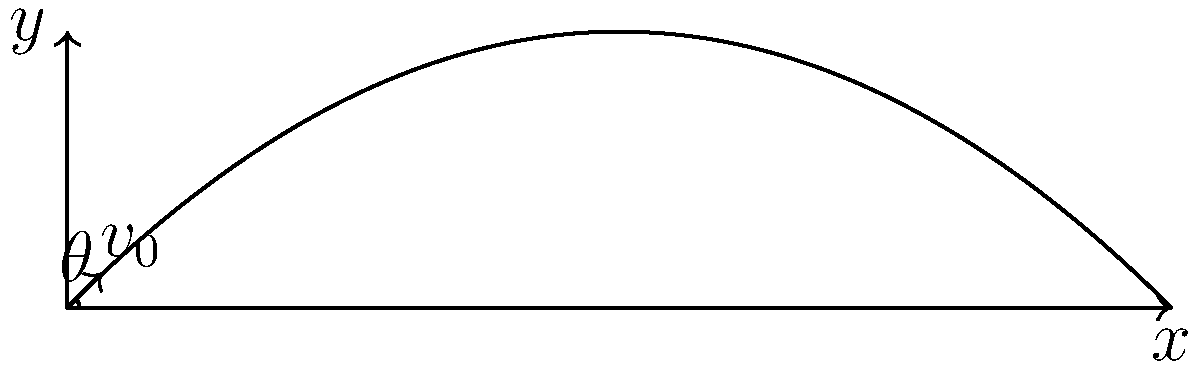As a professional football player, you're practicing your kicks. You kick a football with an initial velocity of 25 m/s at an angle of 45° above the horizontal. Assuming no air resistance, calculate the maximum height reached by the football during its trajectory. To solve this problem, we'll use the equations of projectile motion:

1. Identify the given information:
   - Initial velocity, $v_0 = 25$ m/s
   - Angle of projection, $\theta = 45°$
   - Acceleration due to gravity, $g = 9.8$ m/s²

2. The maximum height is reached when the vertical component of velocity becomes zero. We can use the equation:
   $y_{max} = \frac{v_0^2 \sin^2\theta}{2g}$

3. Convert the angle to radians:
   $45° = \frac{\pi}{4}$ radians

4. Calculate $\sin^2\theta$:
   $\sin^2(\frac{\pi}{4}) = (\frac{\sqrt{2}}{2})^2 = \frac{1}{2}$

5. Substitute the values into the equation:
   $y_{max} = \frac{(25\text{ m/s})^2 \cdot \frac{1}{2}}{2 \cdot 9.8\text{ m/s²}}$

6. Simplify:
   $y_{max} = \frac{625\text{ m²/s²}}{4 \cdot 9.8\text{ m/s²}} = \frac{625}{39.2}\text{ m} \approx 15.94\text{ m}$

Therefore, the maximum height reached by the football is approximately 15.94 meters.
Answer: 15.94 m 